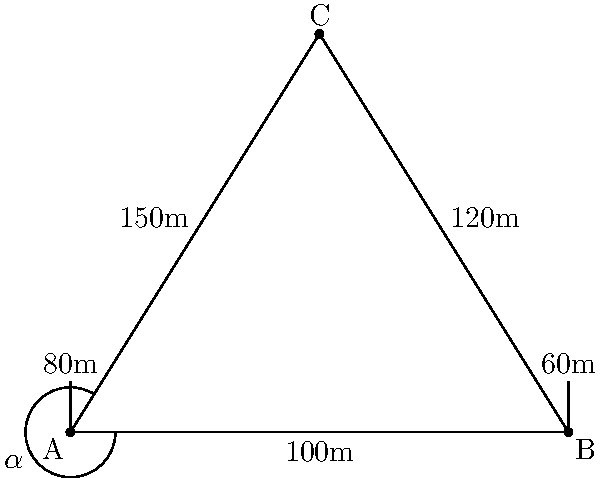As a former radio host, you're familiar with the importance of radio tower placement. Two radio towers, represented by points A and B in the diagram, are 100 meters apart. Tower A is 80 meters tall, and tower B is 60 meters tall. A third point C forms an angle $\alpha$ with the two towers. If the distances AC and BC are 150 meters and 120 meters respectively, what is the measure of angle $\alpha$ in degrees? Let's approach this step-by-step using the law of cosines:

1) In triangle ABC, we know all three sides:
   AB = 100m, AC = 150m, BC = 120m

2) The law of cosines states:
   $c^2 = a^2 + b^2 - 2ab \cos(C)$

3) In our case, angle $\alpha$ is at point A, so we'll use:
   $BC^2 = AB^2 + AC^2 - 2(AB)(AC) \cos(\alpha)$

4) Substituting the known values:
   $120^2 = 100^2 + 150^2 - 2(100)(150) \cos(\alpha)$

5) Simplify:
   $14400 = 10000 + 22500 - 30000 \cos(\alpha)$

6) Subtract 32500 from both sides:
   $-18100 = -30000 \cos(\alpha)$

7) Divide both sides by -30000:
   $\frac{18100}{30000} = \cos(\alpha)$

8) Take the inverse cosine (arccos) of both sides:
   $\alpha = \arccos(\frac{18100}{30000})$

9) Calculate:
   $\alpha \approx 53.13°$

Therefore, the measure of angle $\alpha$ is approximately 53.13 degrees.
Answer: $53.13°$ 